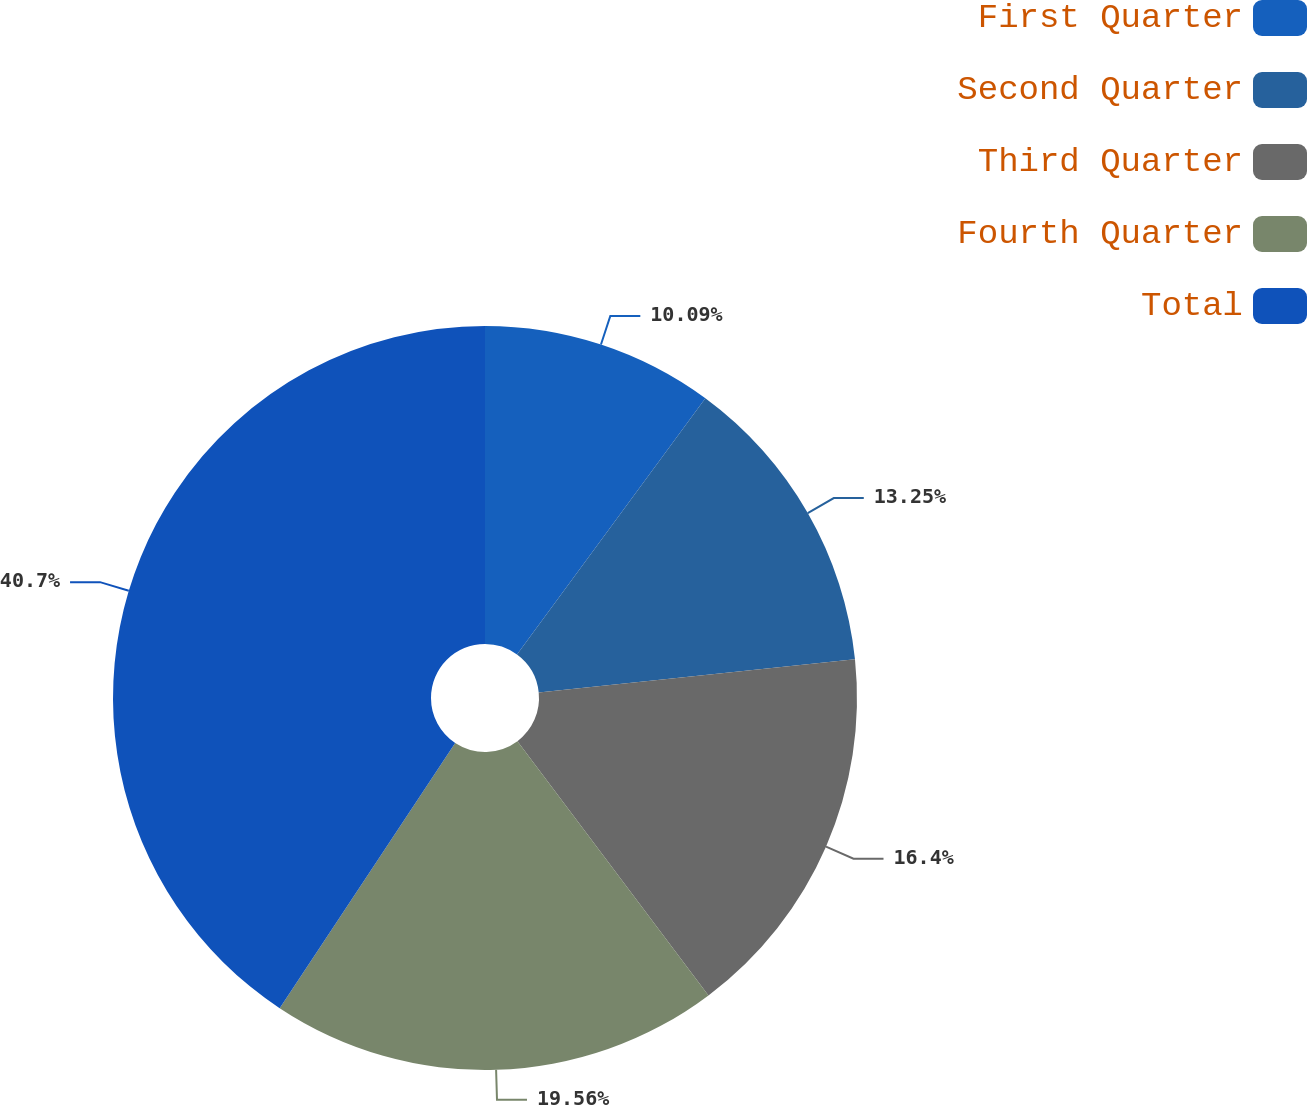Convert chart to OTSL. <chart><loc_0><loc_0><loc_500><loc_500><pie_chart><fcel>First Quarter<fcel>Second Quarter<fcel>Third Quarter<fcel>Fourth Quarter<fcel>Total<nl><fcel>10.09%<fcel>13.25%<fcel>16.4%<fcel>19.56%<fcel>40.69%<nl></chart> 